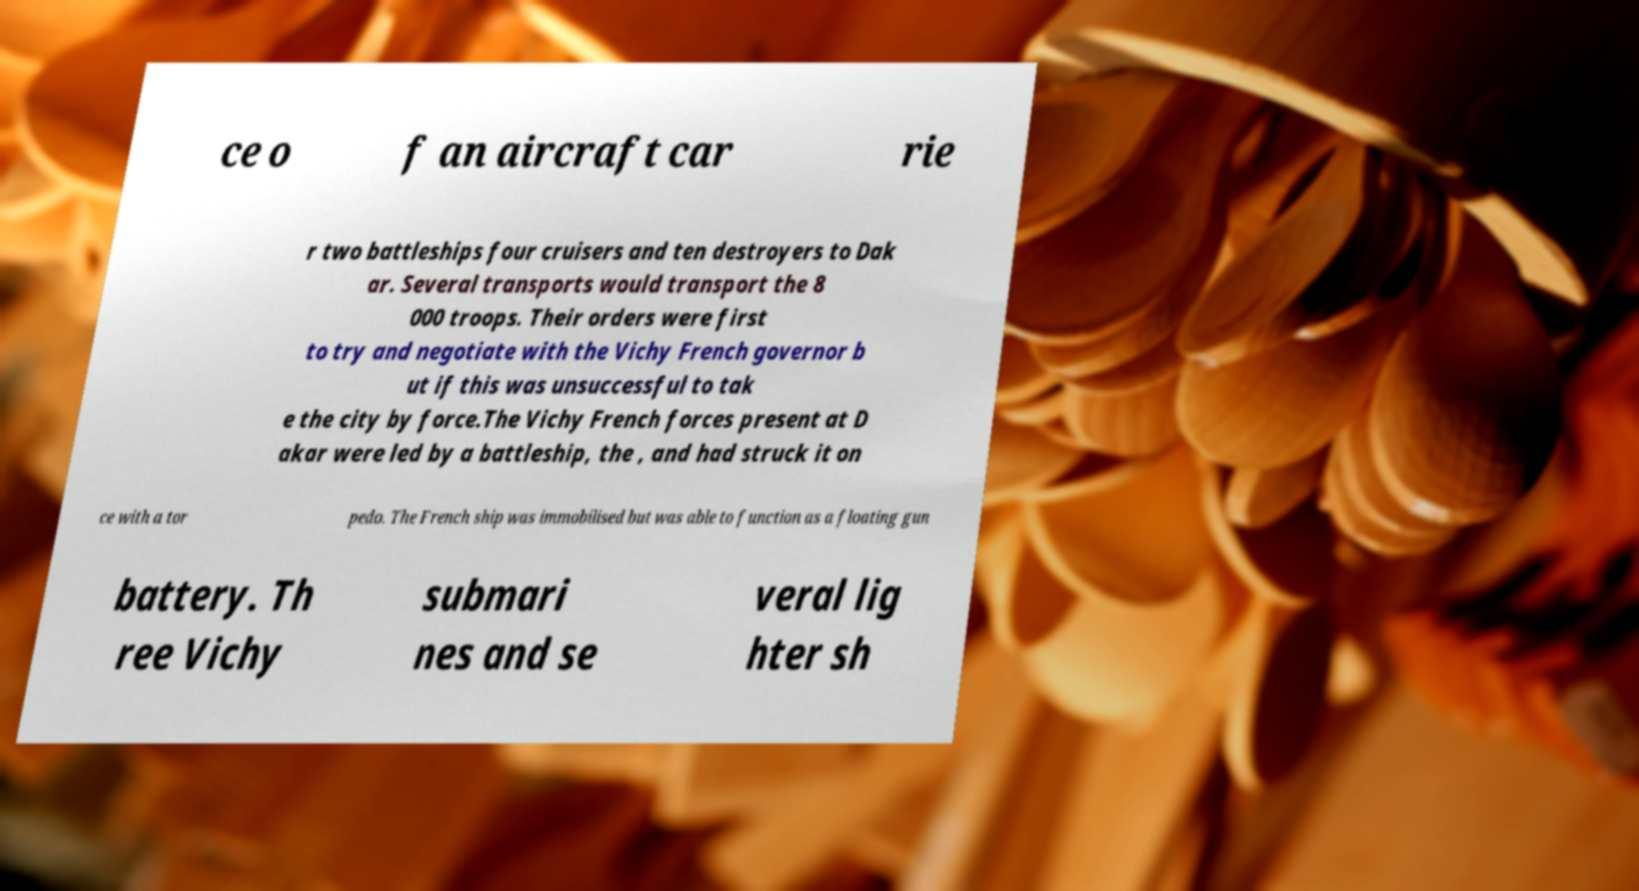I need the written content from this picture converted into text. Can you do that? ce o f an aircraft car rie r two battleships four cruisers and ten destroyers to Dak ar. Several transports would transport the 8 000 troops. Their orders were first to try and negotiate with the Vichy French governor b ut if this was unsuccessful to tak e the city by force.The Vichy French forces present at D akar were led by a battleship, the , and had struck it on ce with a tor pedo. The French ship was immobilised but was able to function as a floating gun battery. Th ree Vichy submari nes and se veral lig hter sh 